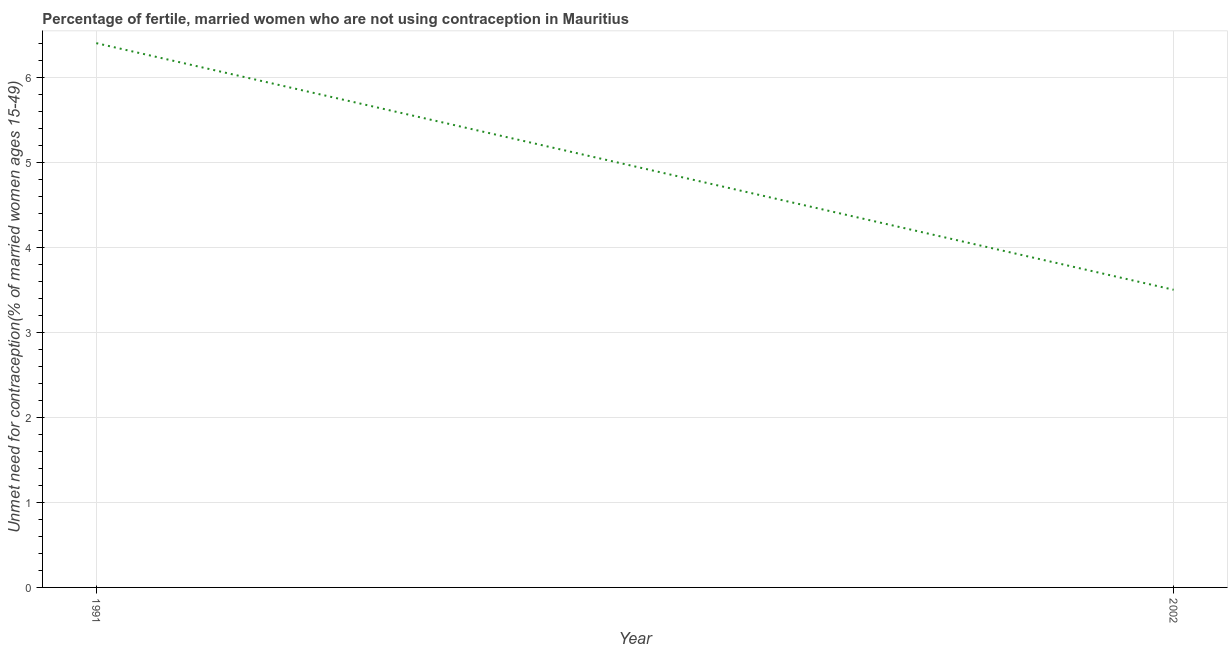Across all years, what is the maximum number of married women who are not using contraception?
Provide a short and direct response. 6.4. In which year was the number of married women who are not using contraception maximum?
Offer a very short reply. 1991. In which year was the number of married women who are not using contraception minimum?
Your answer should be very brief. 2002. What is the sum of the number of married women who are not using contraception?
Keep it short and to the point. 9.9. What is the difference between the number of married women who are not using contraception in 1991 and 2002?
Give a very brief answer. 2.9. What is the average number of married women who are not using contraception per year?
Give a very brief answer. 4.95. What is the median number of married women who are not using contraception?
Your answer should be compact. 4.95. Do a majority of the years between 2002 and 1991 (inclusive) have number of married women who are not using contraception greater than 3.2 %?
Provide a short and direct response. No. What is the ratio of the number of married women who are not using contraception in 1991 to that in 2002?
Give a very brief answer. 1.83. Is the number of married women who are not using contraception in 1991 less than that in 2002?
Give a very brief answer. No. How many lines are there?
Your answer should be very brief. 1. How many years are there in the graph?
Give a very brief answer. 2. What is the difference between two consecutive major ticks on the Y-axis?
Ensure brevity in your answer.  1. Are the values on the major ticks of Y-axis written in scientific E-notation?
Make the answer very short. No. What is the title of the graph?
Your answer should be compact. Percentage of fertile, married women who are not using contraception in Mauritius. What is the label or title of the X-axis?
Ensure brevity in your answer.  Year. What is the label or title of the Y-axis?
Provide a succinct answer.  Unmet need for contraception(% of married women ages 15-49). What is the  Unmet need for contraception(% of married women ages 15-49) in 1991?
Provide a short and direct response. 6.4. What is the  Unmet need for contraception(% of married women ages 15-49) of 2002?
Your answer should be compact. 3.5. What is the ratio of the  Unmet need for contraception(% of married women ages 15-49) in 1991 to that in 2002?
Provide a short and direct response. 1.83. 